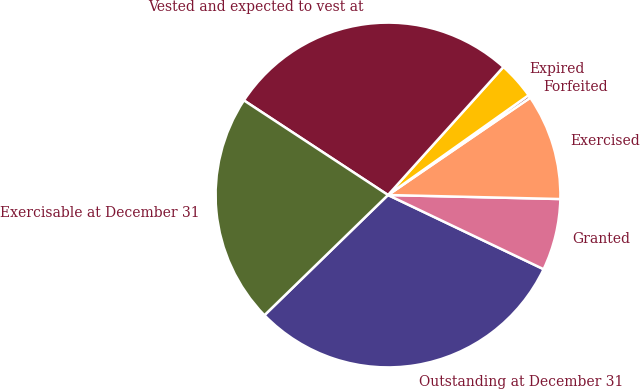Convert chart to OTSL. <chart><loc_0><loc_0><loc_500><loc_500><pie_chart><fcel>Outstanding at December 31<fcel>Granted<fcel>Exercised<fcel>Forfeited<fcel>Expired<fcel>Vested and expected to vest at<fcel>Exercisable at December 31<nl><fcel>30.64%<fcel>6.71%<fcel>9.92%<fcel>0.28%<fcel>3.5%<fcel>27.43%<fcel>21.53%<nl></chart> 